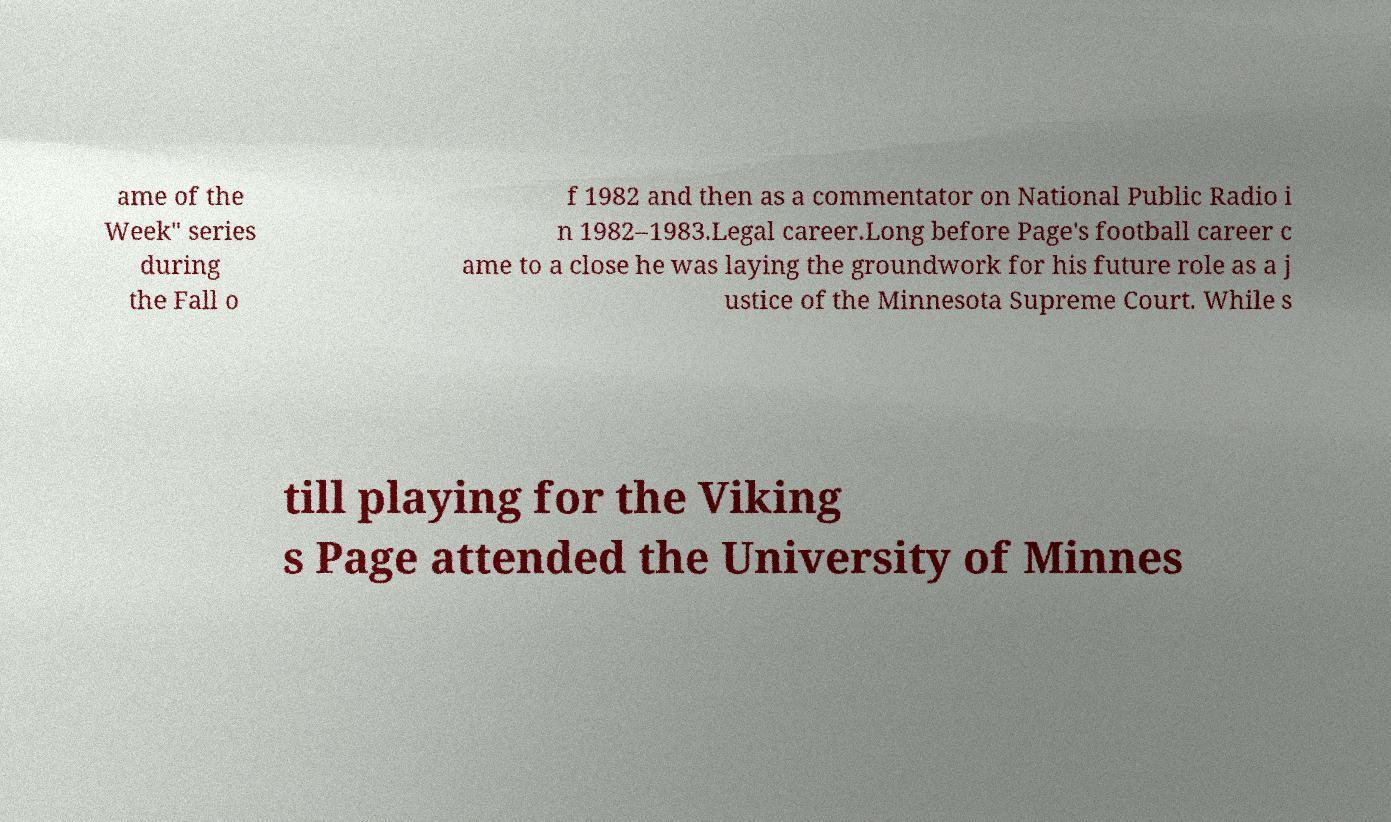Please identify and transcribe the text found in this image. ame of the Week" series during the Fall o f 1982 and then as a commentator on National Public Radio i n 1982–1983.Legal career.Long before Page's football career c ame to a close he was laying the groundwork for his future role as a j ustice of the Minnesota Supreme Court. While s till playing for the Viking s Page attended the University of Minnes 